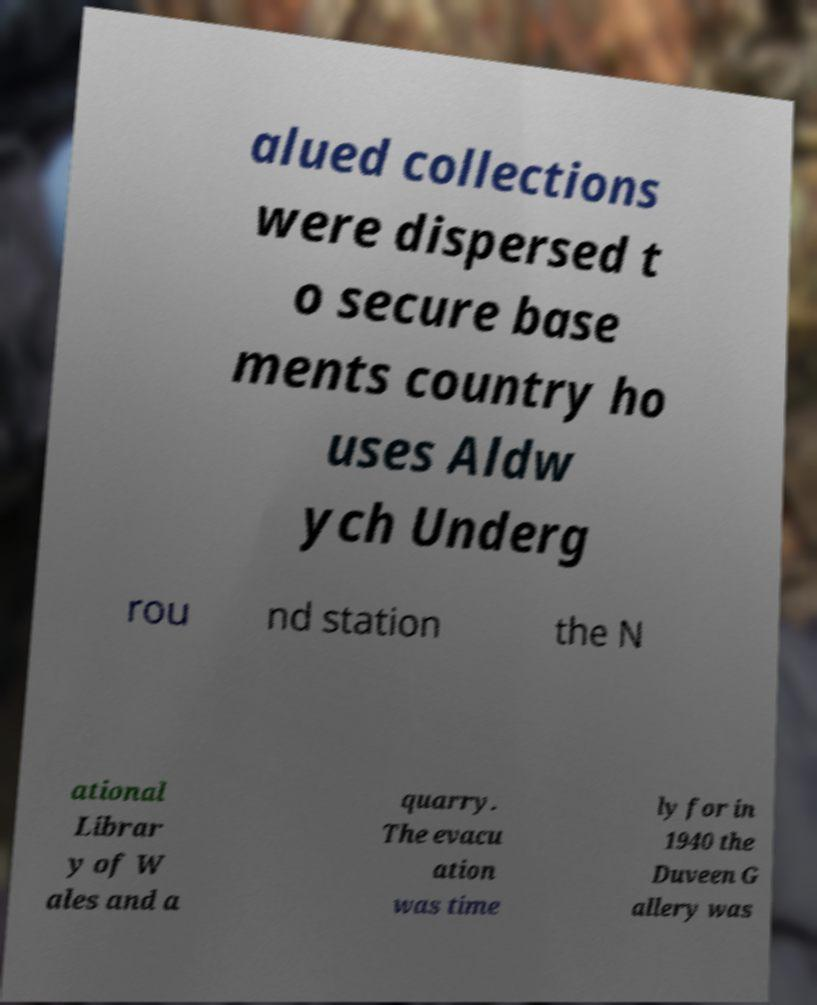There's text embedded in this image that I need extracted. Can you transcribe it verbatim? alued collections were dispersed t o secure base ments country ho uses Aldw ych Underg rou nd station the N ational Librar y of W ales and a quarry. The evacu ation was time ly for in 1940 the Duveen G allery was 